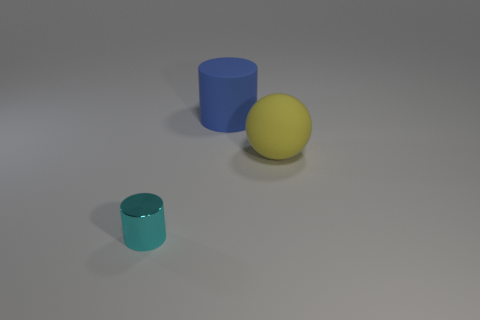Is there any sense of depth or distance between the objects? Yes, there is. The yellow sphere and the blue cylinder appear closer to the viewer, whereas the smaller teal cylinder looks to be placed further back, creating a perception of depth in the scene. Does this arrangement suggest anything about the positioning or scale of the objects? It suggests that the objects are arranged intentionally to provide a sense of space and size variation, with the larger shapes at the forefront and the smaller one receding, contributing to a composition with a clear visual hierarchy. 